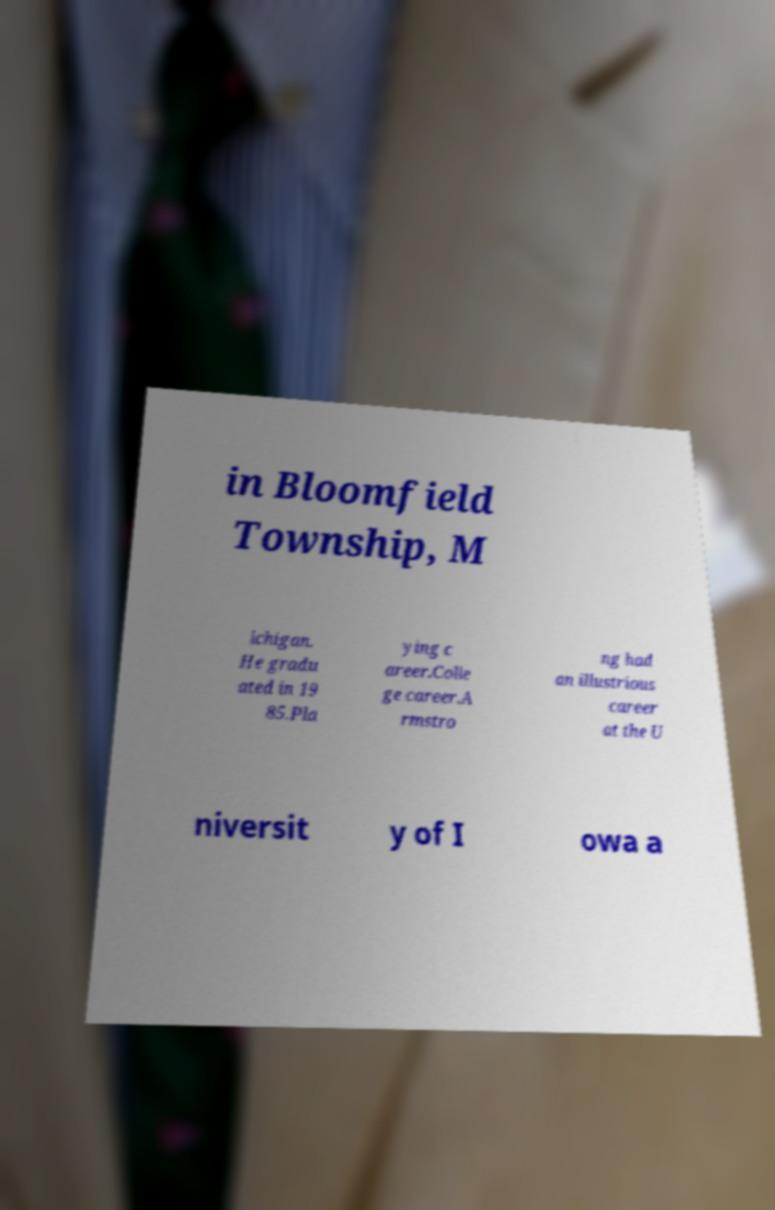Please read and relay the text visible in this image. What does it say? in Bloomfield Township, M ichigan. He gradu ated in 19 85.Pla ying c areer.Colle ge career.A rmstro ng had an illustrious career at the U niversit y of I owa a 